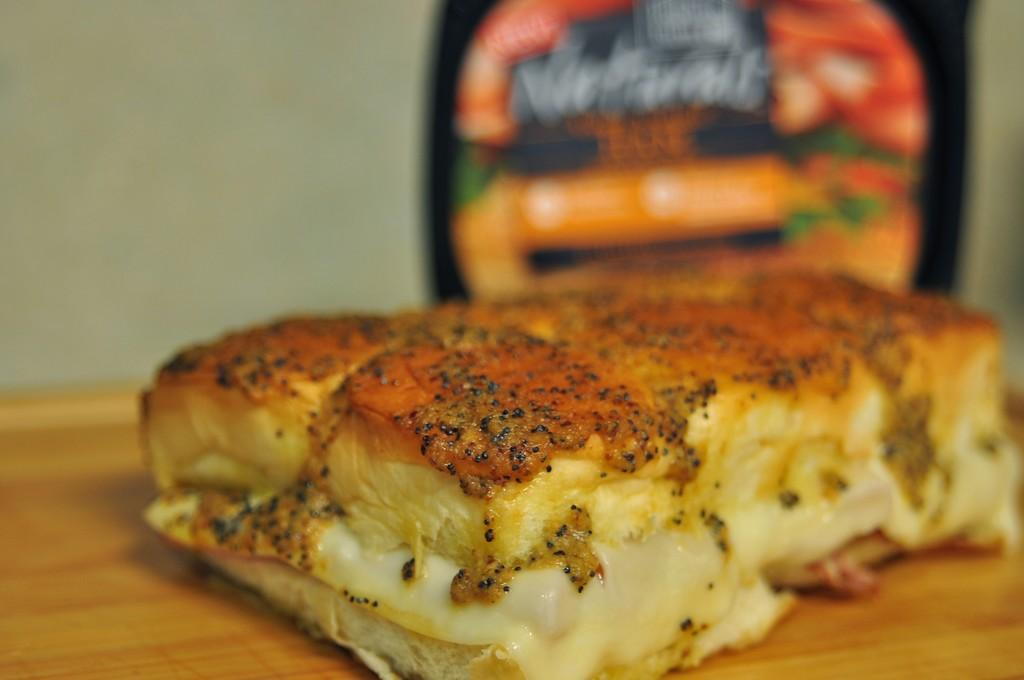What is the main object in the center of the image? There is a table in the center of the image. What is on the table? There are food items on the table. What can be seen in the background of the image? There is a wall and a banner in the background of the image. How much debt is represented by the food items on the table? There is no indication of debt in the image; it only shows food items on a table. What type of knife is being used to cut the food in the image? There is no knife visible in the image; only food items and a table are present. 